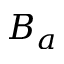<formula> <loc_0><loc_0><loc_500><loc_500>B _ { a }</formula> 